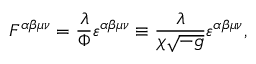Convert formula to latex. <formula><loc_0><loc_0><loc_500><loc_500>F ^ { \alpha \beta \mu \nu } = \frac { \lambda } { \Phi } \varepsilon ^ { \alpha \beta \mu \nu } \equiv \frac { \lambda } { \chi \sqrt { - g } } \varepsilon ^ { \alpha \beta \mu \nu } ,</formula> 